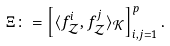Convert formula to latex. <formula><loc_0><loc_0><loc_500><loc_500>\Xi \colon = \left [ \langle f ^ { i } _ { \mathcal { Z } } , f ^ { j } _ { \mathcal { Z } } \rangle _ { \mathcal { K } } \right ] _ { i , j = 1 } ^ { p } .</formula> 